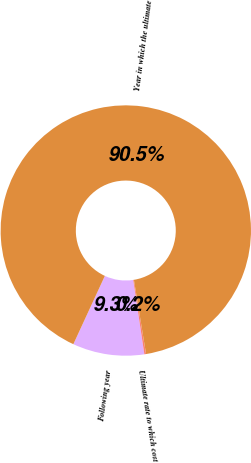Convert chart. <chart><loc_0><loc_0><loc_500><loc_500><pie_chart><fcel>Following year<fcel>Ultimate rate to which cost<fcel>Year in which the ultimate<nl><fcel>9.25%<fcel>0.22%<fcel>90.52%<nl></chart> 